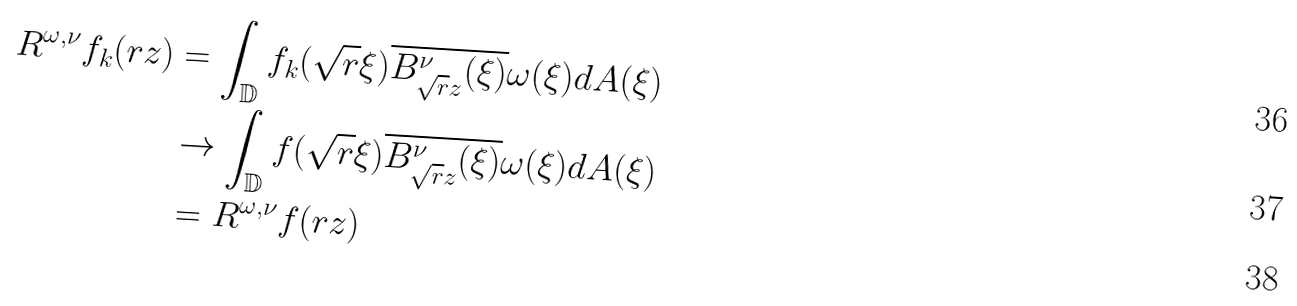Convert formula to latex. <formula><loc_0><loc_0><loc_500><loc_500>R ^ { \omega , \nu } f _ { k } ( r z ) & = \int _ { \mathbb { D } } f _ { k } ( \sqrt { r } \xi ) \overline { B _ { \sqrt { r } z } ^ { \nu } ( \xi ) } \omega ( \xi ) d A ( \xi ) \\ & \to \int _ { \mathbb { D } } f ( \sqrt { r } \xi ) \overline { B _ { \sqrt { r } z } ^ { \nu } ( \xi ) } \omega ( \xi ) d A ( \xi ) \\ & = R ^ { \omega , \nu } f ( r z )</formula> 